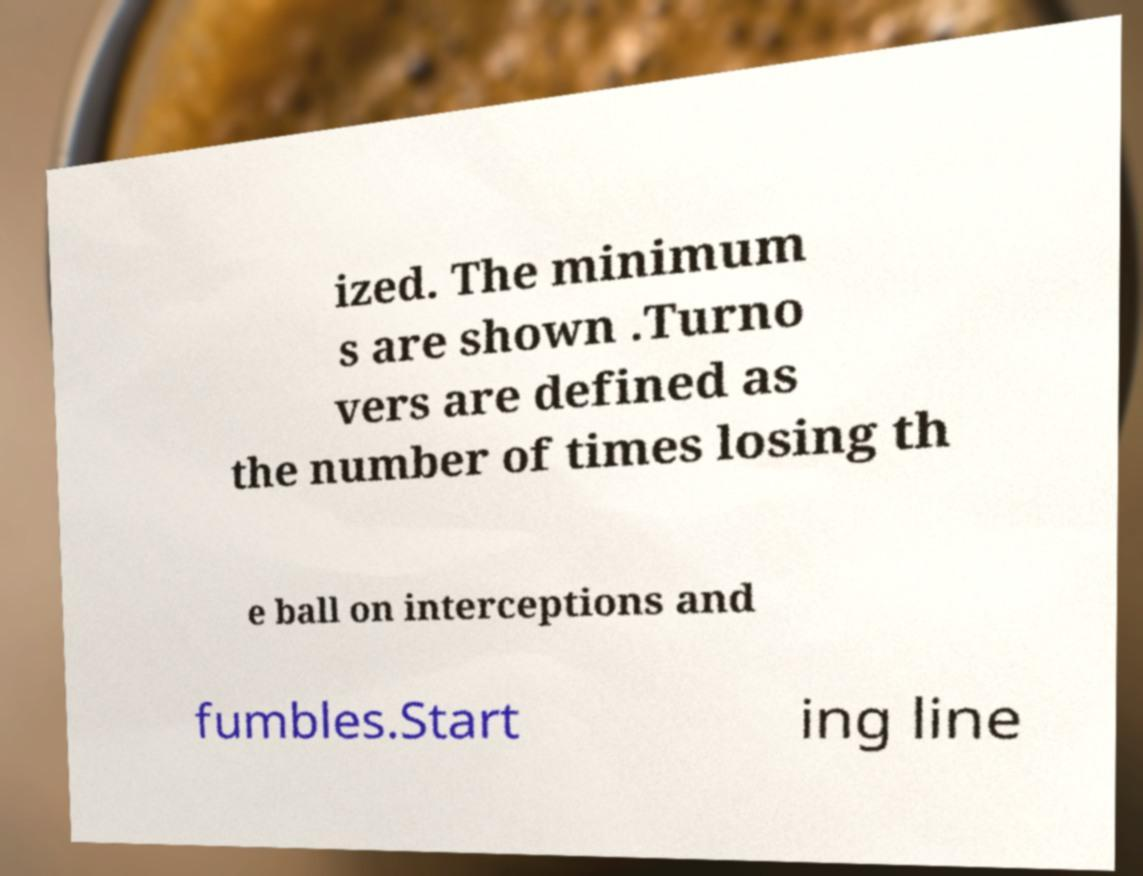For documentation purposes, I need the text within this image transcribed. Could you provide that? ized. The minimum s are shown .Turno vers are defined as the number of times losing th e ball on interceptions and fumbles.Start ing line 